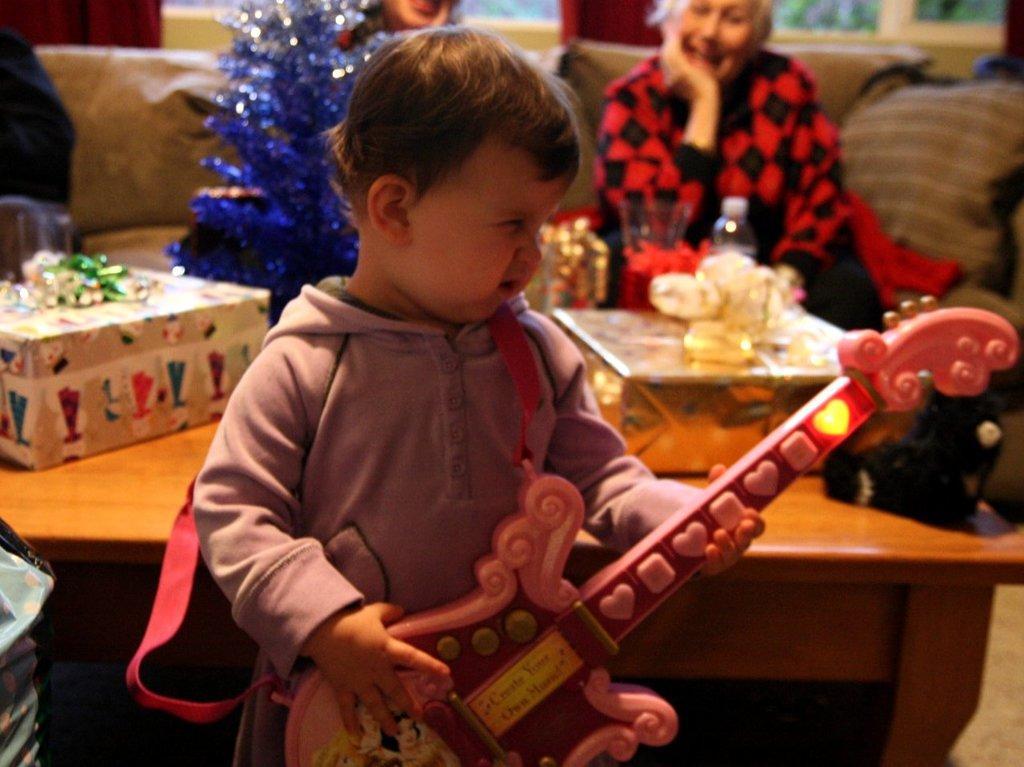In one or two sentences, can you explain what this image depicts? A boy is holding guitar in his hands. Behind him there are gifts on the table and two persons sitting on the chair. 